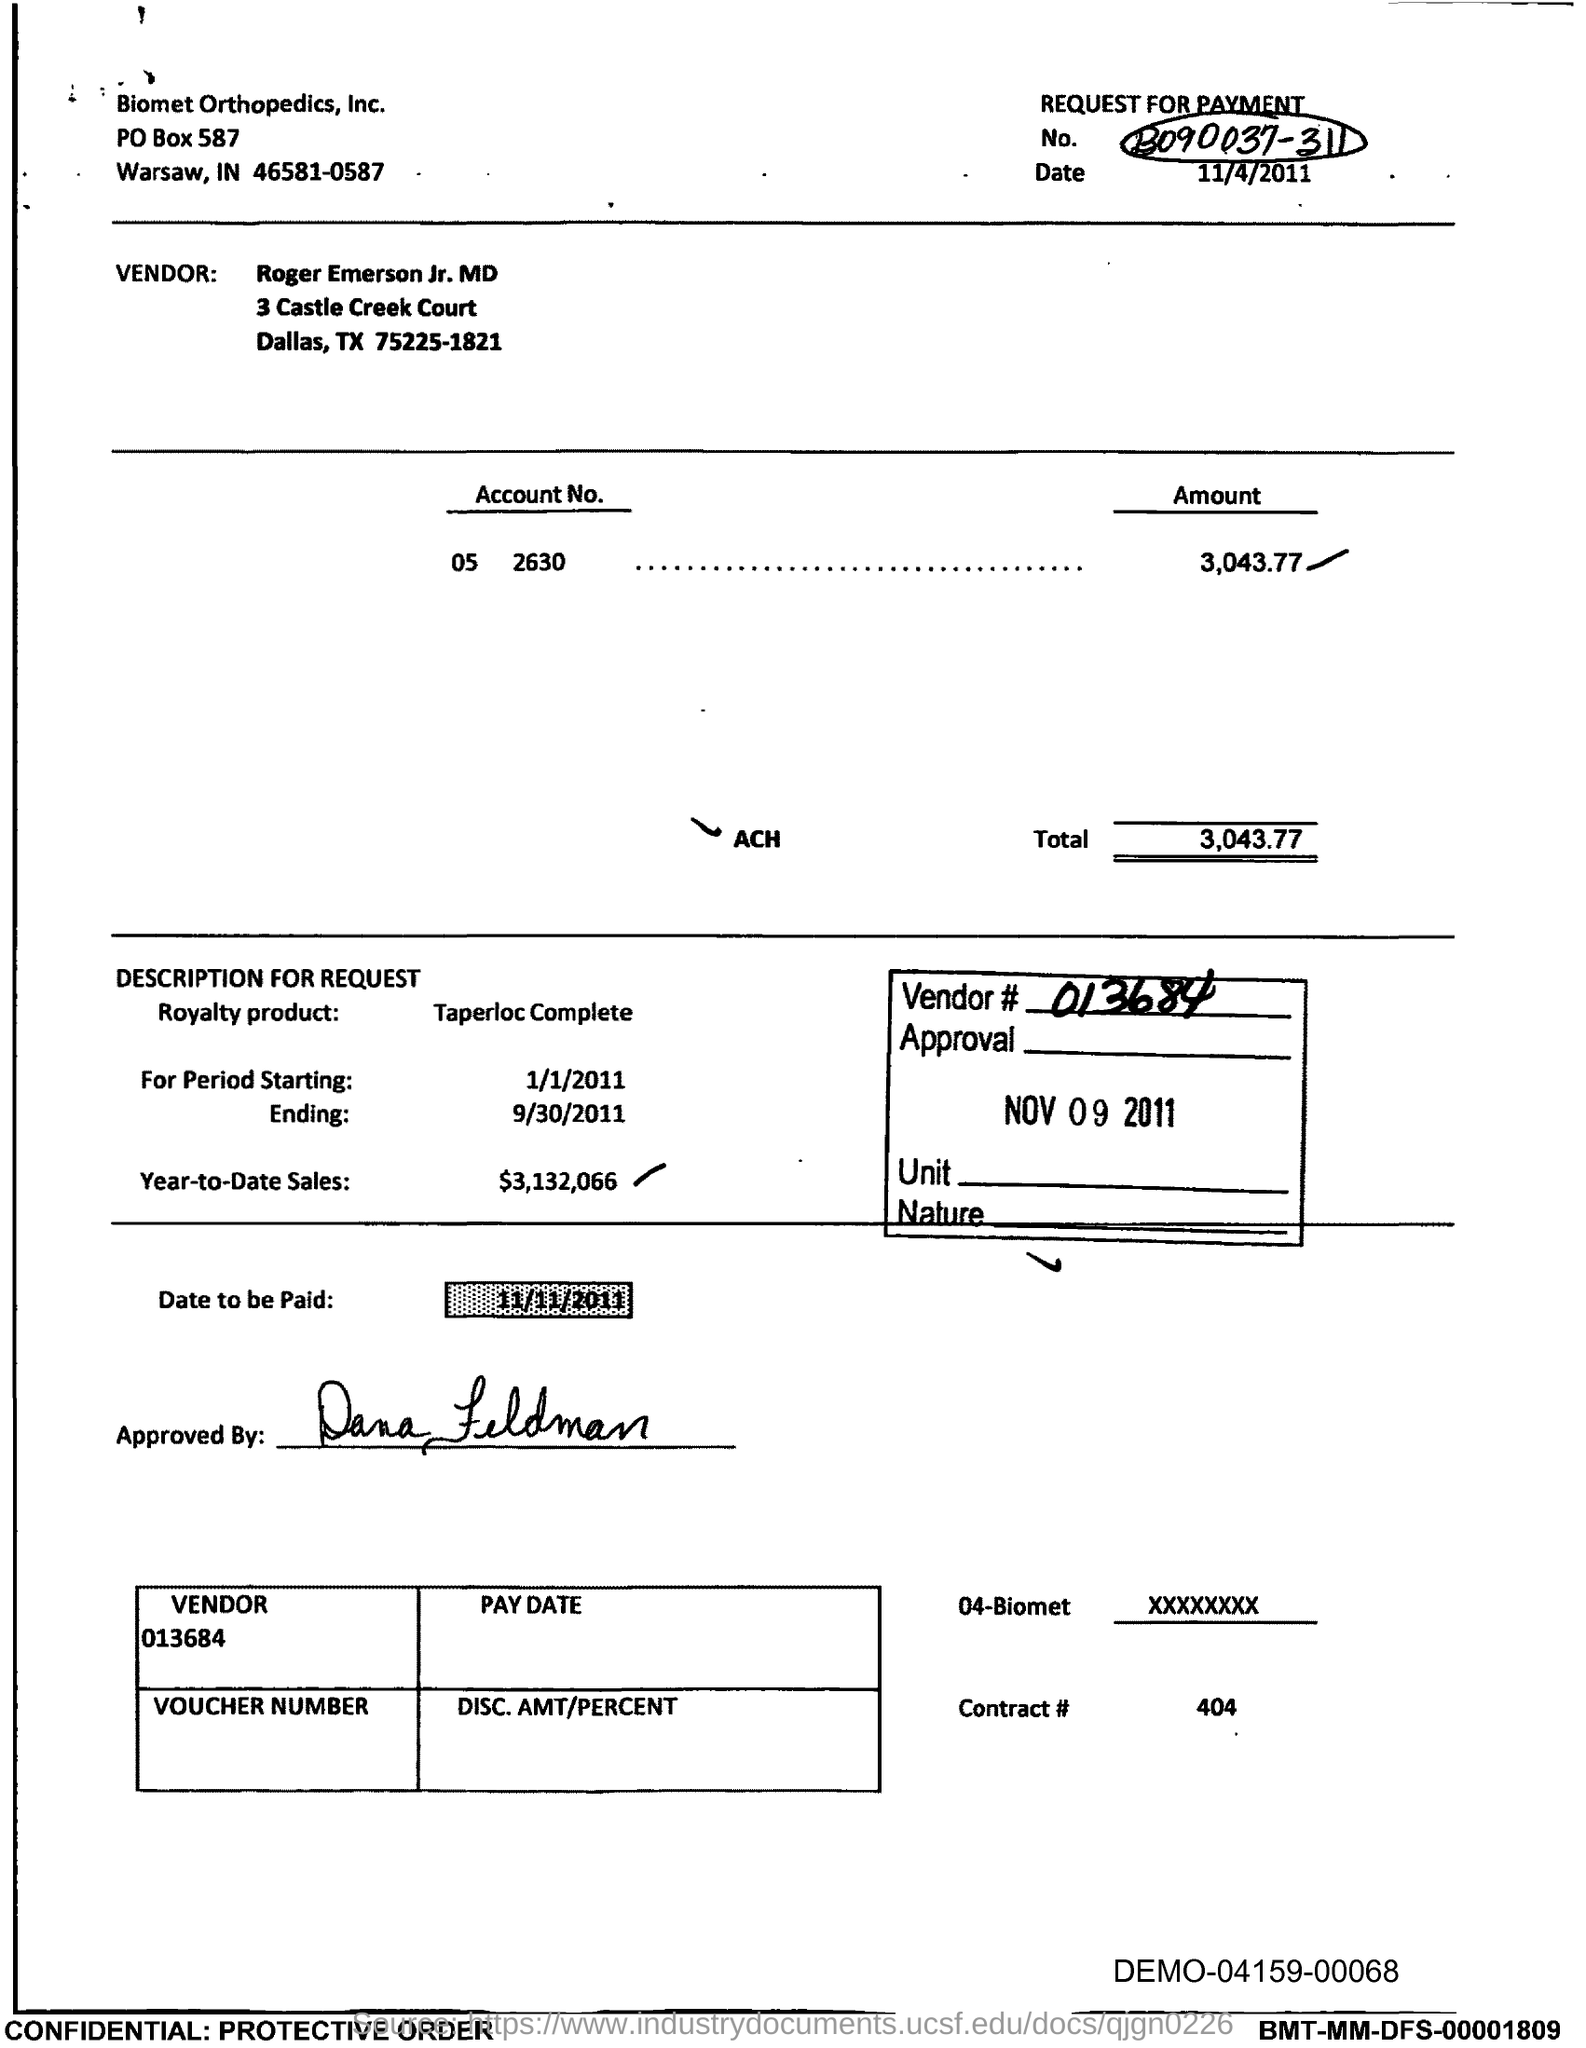Mention a couple of crucial points in this snapshot. The year-to-date sales of the royalty product are $3,132,066. Biomet Orthopedics, Inc. is the company mentioned in the header of the document. The royalty product mentioned in the document is Taperloc Complete. The vendor number provided in the document is 013684. The account number provided in the document is 05 2630. 